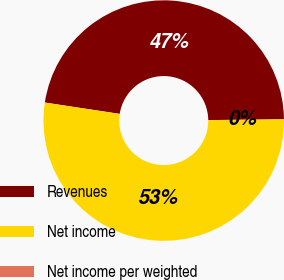Convert chart to OTSL. <chart><loc_0><loc_0><loc_500><loc_500><pie_chart><fcel>Revenues<fcel>Net income<fcel>Net income per weighted<nl><fcel>47.44%<fcel>52.56%<fcel>0.0%<nl></chart> 